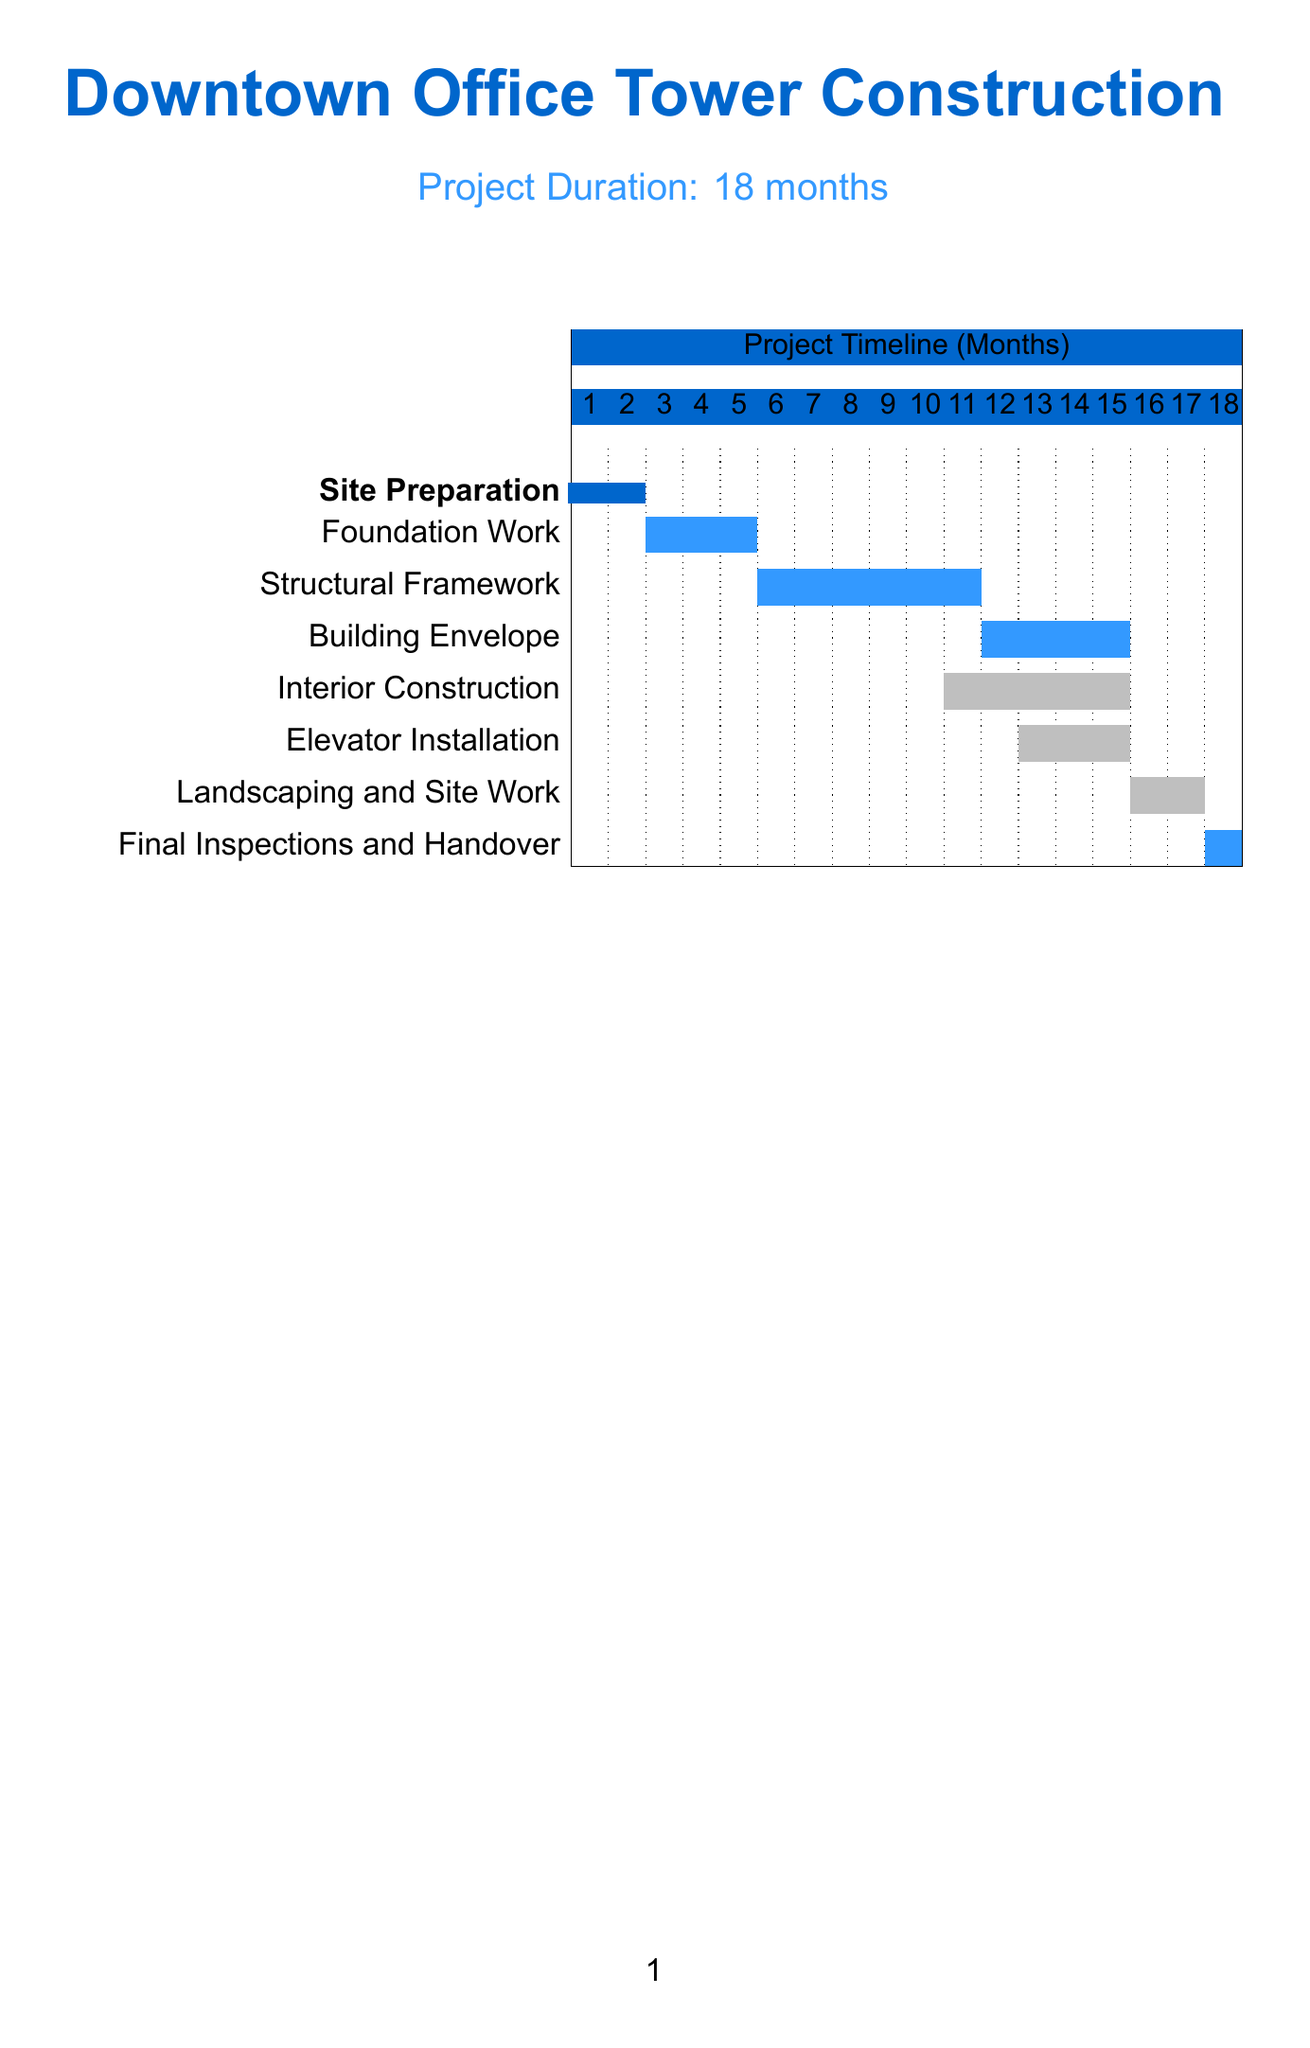What is the total project duration? The total project duration is stated as "18 months" in the document.
Answer: 18 months How many critical path milestones are there? The document lists four critical path milestones under the "Milestone" section.
Answer: 4 What is the buffer period for Foundation Work? The buffer period for Foundation Work is indicated as "3 weeks" next to that milestone.
Answer: 3 weeks Which milestone has the longest duration? The milestone with the longest duration is "Structural Framework," which lasts for "6 months."
Answer: Structural Framework What is a measure to reduce long-term costs? Among the cost-saving measures, "Use of energy-efficient materials and systems to reduce long-term costs" is mentioned in the document.
Answer: Use of energy-efficient materials and systems What starts immediately after "Building Envelope"? According to the timeline in the document, "Interior Construction" starts after "Building Envelope."
Answer: Interior Construction What is the buffer for the final milestone? The buffer for the final milestone, "Final Inspections and Handover," is shown as "1 week" in the table.
Answer: 1 week How many months are allocated for Landscaping and Site Work? The document specifies "2 months" for the duration of Landscaping and Site Work.
Answer: 2 months 